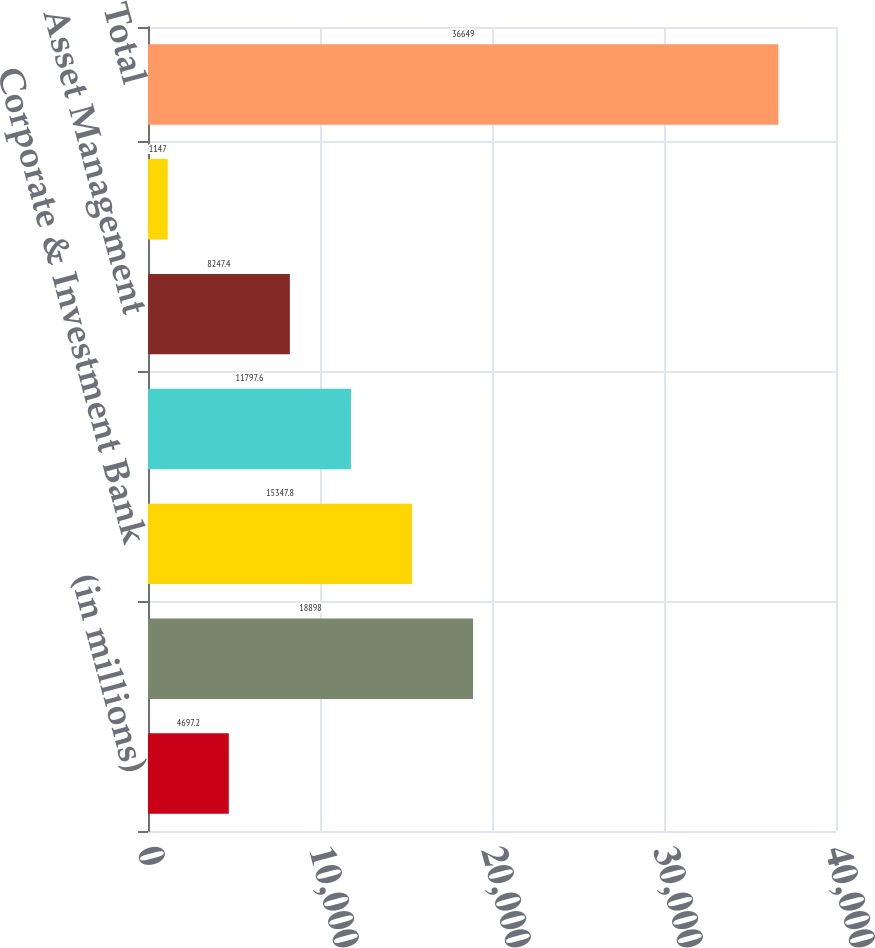Convert chart. <chart><loc_0><loc_0><loc_500><loc_500><bar_chart><fcel>(in millions)<fcel>Consumer & Community Banking<fcel>Corporate & Investment Bank<fcel>Commercial Banking<fcel>Asset Management<fcel>Corporate<fcel>Total<nl><fcel>4697.2<fcel>18898<fcel>15347.8<fcel>11797.6<fcel>8247.4<fcel>1147<fcel>36649<nl></chart> 